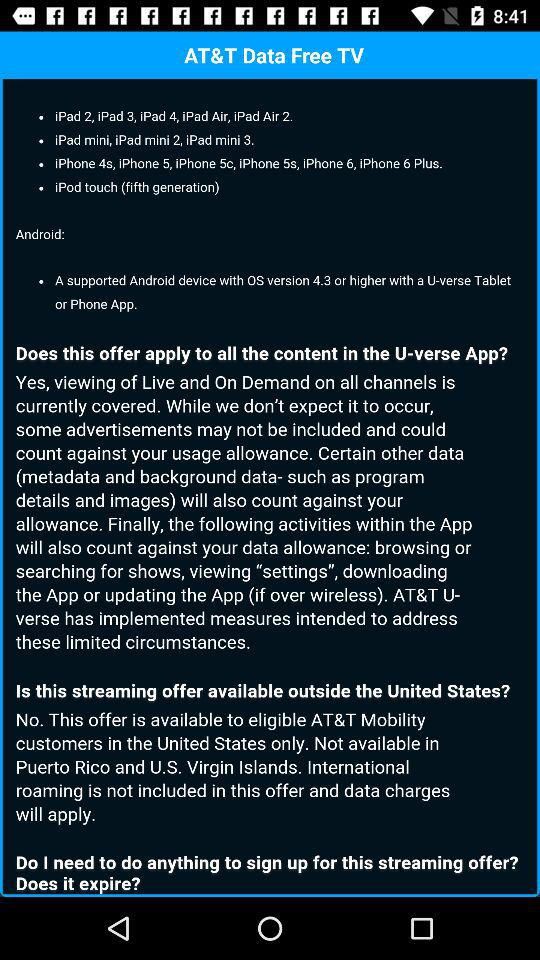What generation of iPod touch is available? The iPod touch is available in fifth generation. 